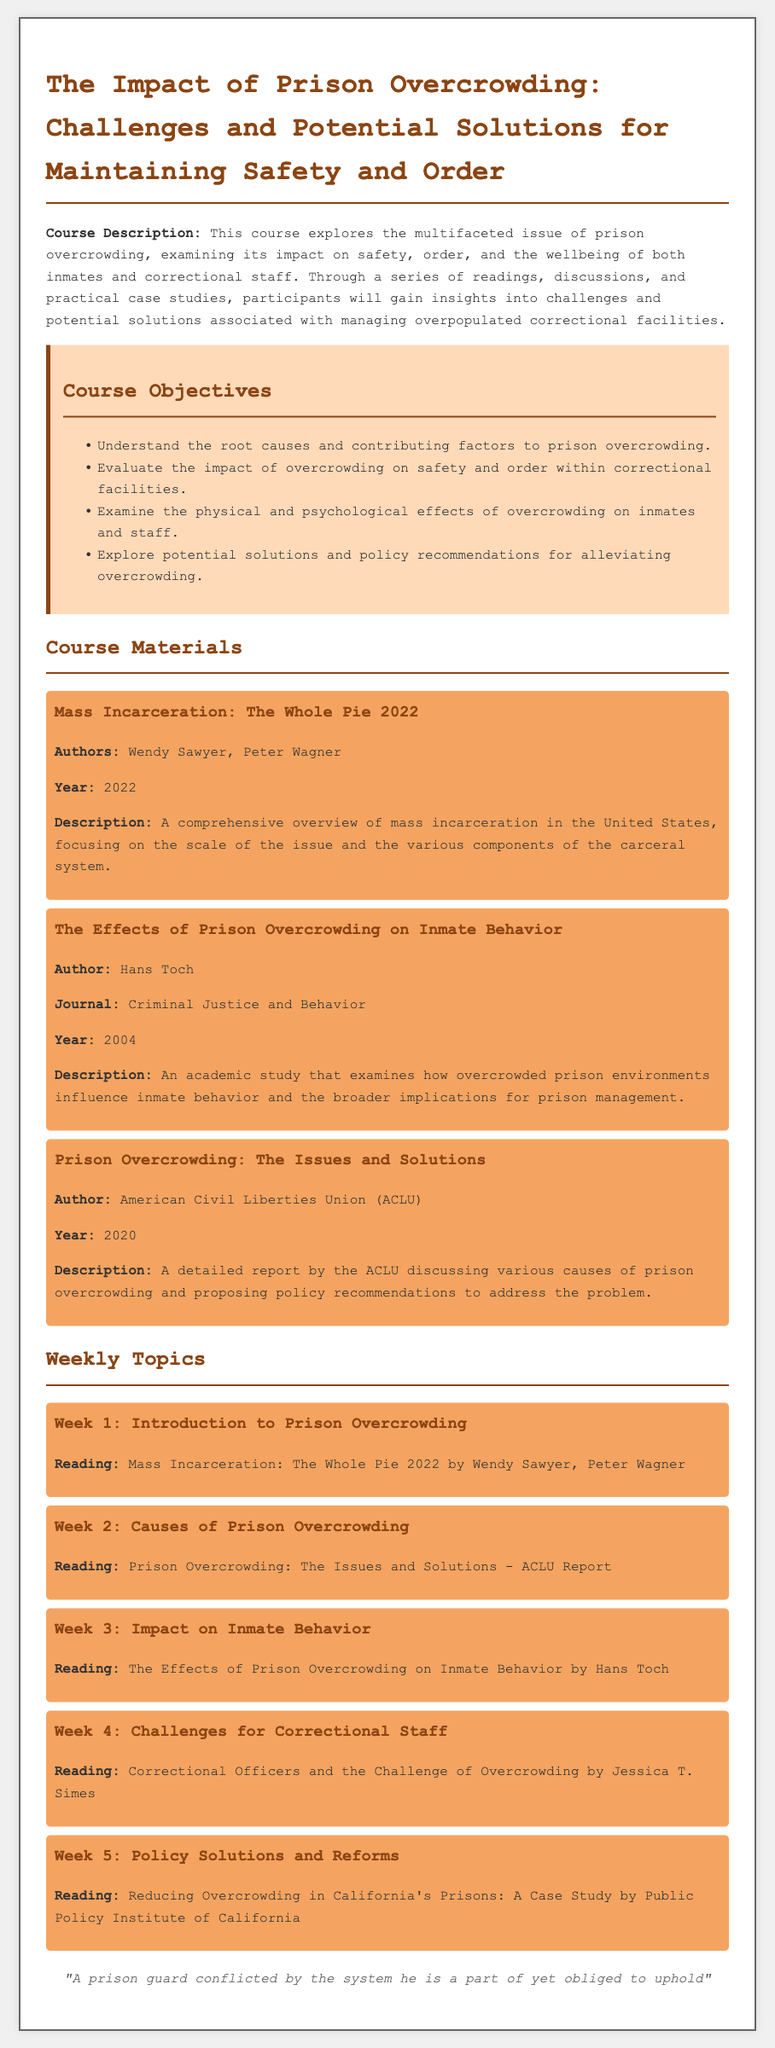what is the course title? The course title is explicitly stated at the beginning of the document.
Answer: The Impact of Prison Overcrowding: Challenges and Potential Solutions for Maintaining Safety and Order who are the authors of the first course material? The names of the authors are provided under the first course material section.
Answer: Wendy Sawyer, Peter Wagner what year was the ACLU report published? The year of publication is mentioned in the ACLU report description.
Answer: 2020 which week focuses on challenges for correctional staff? The weeks and their focus topics are outlined under the weekly topics section.
Answer: Week 4 what are the two main subjects covered by the course objectives? The course objectives list two main subjects that the course will cover.
Answer: Root causes and impact on safety who authored the study on inmate behavior? The author of the specific study is provided in the document under the second course material.
Answer: Hans Toch how many weeks are covered in the syllabus? The weekly topics section lists the number of weeks addressed in the course.
Answer: Five what type of reading is associated with Week 5? Each week correlates to a specific reading, as stated in the weekly topics section.
Answer: Case Study 